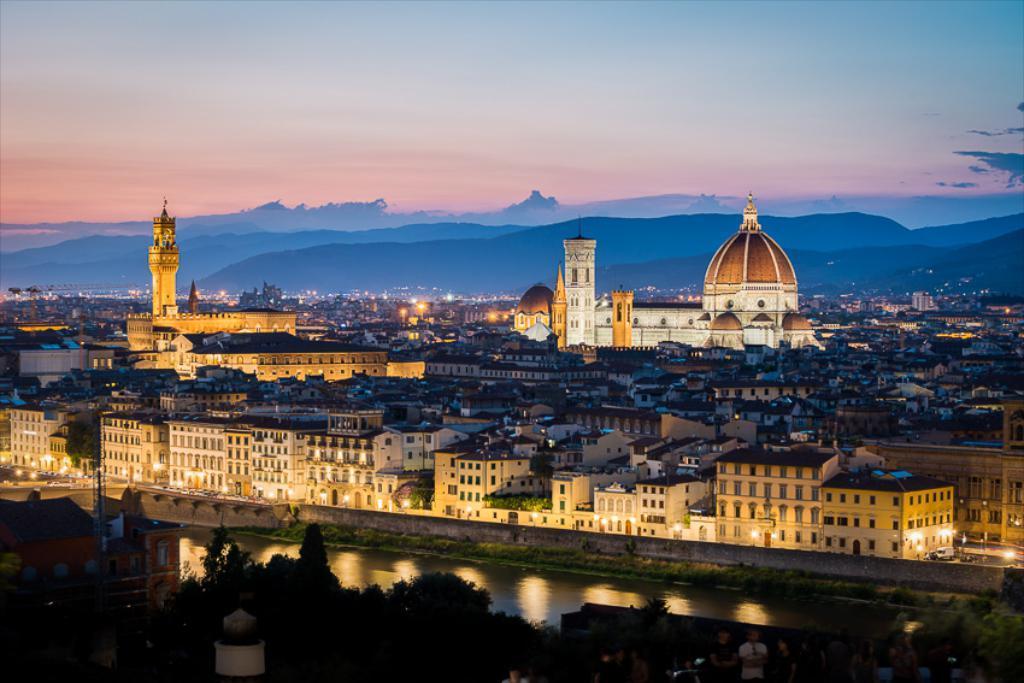How would you summarize this image in a sentence or two? In the center of the image there are buildings. At the bottom there is a canal and we can see trees. In the background there are hills and sky. 